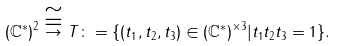<formula> <loc_0><loc_0><loc_500><loc_500>( \mathbb { C } ^ { \ast } ) ^ { 2 } \stackrel { \cong } { \to } T \colon = \{ ( t _ { 1 } , t _ { 2 } , t _ { 3 } ) \in ( \mathbb { C } ^ { \ast } ) ^ { \times 3 } | t _ { 1 } t _ { 2 } t _ { 3 } = 1 \} .</formula> 